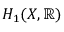Convert formula to latex. <formula><loc_0><loc_0><loc_500><loc_500>H _ { 1 } ( X , \mathbb { R } )</formula> 